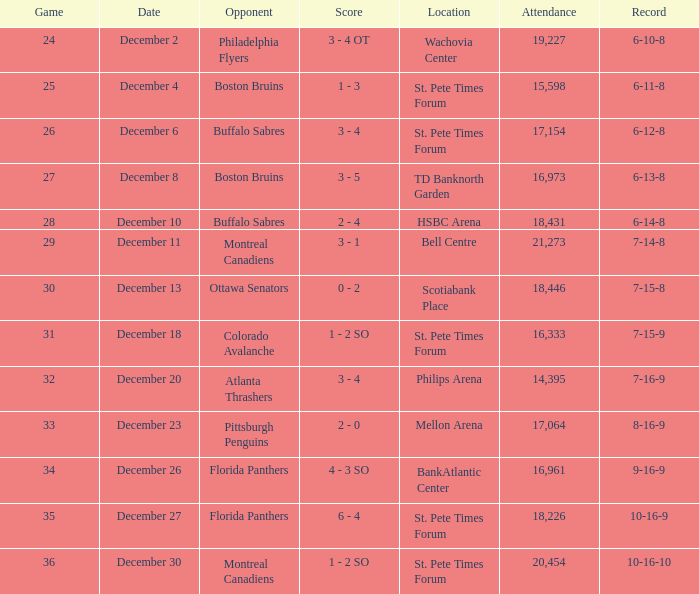What is the location of the game with a 6-11-8 record? St. Pete Times Forum. Give me the full table as a dictionary. {'header': ['Game', 'Date', 'Opponent', 'Score', 'Location', 'Attendance', 'Record'], 'rows': [['24', 'December 2', 'Philadelphia Flyers', '3 - 4 OT', 'Wachovia Center', '19,227', '6-10-8'], ['25', 'December 4', 'Boston Bruins', '1 - 3', 'St. Pete Times Forum', '15,598', '6-11-8'], ['26', 'December 6', 'Buffalo Sabres', '3 - 4', 'St. Pete Times Forum', '17,154', '6-12-8'], ['27', 'December 8', 'Boston Bruins', '3 - 5', 'TD Banknorth Garden', '16,973', '6-13-8'], ['28', 'December 10', 'Buffalo Sabres', '2 - 4', 'HSBC Arena', '18,431', '6-14-8'], ['29', 'December 11', 'Montreal Canadiens', '3 - 1', 'Bell Centre', '21,273', '7-14-8'], ['30', 'December 13', 'Ottawa Senators', '0 - 2', 'Scotiabank Place', '18,446', '7-15-8'], ['31', 'December 18', 'Colorado Avalanche', '1 - 2 SO', 'St. Pete Times Forum', '16,333', '7-15-9'], ['32', 'December 20', 'Atlanta Thrashers', '3 - 4', 'Philips Arena', '14,395', '7-16-9'], ['33', 'December 23', 'Pittsburgh Penguins', '2 - 0', 'Mellon Arena', '17,064', '8-16-9'], ['34', 'December 26', 'Florida Panthers', '4 - 3 SO', 'BankAtlantic Center', '16,961', '9-16-9'], ['35', 'December 27', 'Florida Panthers', '6 - 4', 'St. Pete Times Forum', '18,226', '10-16-9'], ['36', 'December 30', 'Montreal Canadiens', '1 - 2 SO', 'St. Pete Times Forum', '20,454', '10-16-10']]} 